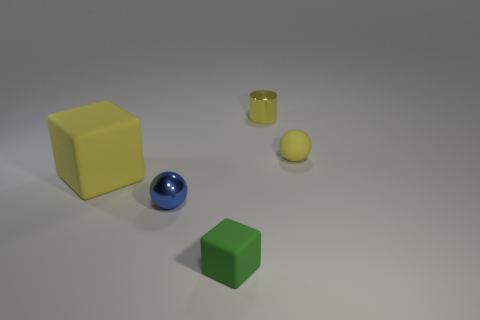Add 3 tiny blue things. How many objects exist? 8 Subtract all cylinders. How many objects are left? 4 Add 4 rubber cubes. How many rubber cubes are left? 6 Add 4 green metal cubes. How many green metal cubes exist? 4 Subtract 0 purple balls. How many objects are left? 5 Subtract all tiny blue metal spheres. Subtract all brown matte cylinders. How many objects are left? 4 